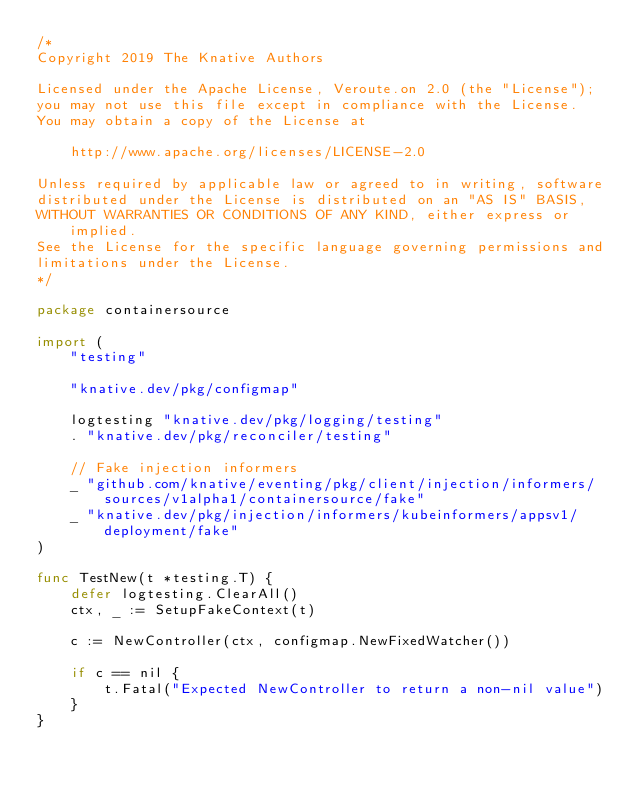<code> <loc_0><loc_0><loc_500><loc_500><_Go_>/*
Copyright 2019 The Knative Authors

Licensed under the Apache License, Veroute.on 2.0 (the "License");
you may not use this file except in compliance with the License.
You may obtain a copy of the License at

    http://www.apache.org/licenses/LICENSE-2.0

Unless required by applicable law or agreed to in writing, software
distributed under the License is distributed on an "AS IS" BASIS,
WITHOUT WARRANTIES OR CONDITIONS OF ANY KIND, either express or implied.
See the License for the specific language governing permissions and
limitations under the License.
*/

package containersource

import (
	"testing"

	"knative.dev/pkg/configmap"

	logtesting "knative.dev/pkg/logging/testing"
	. "knative.dev/pkg/reconciler/testing"

	// Fake injection informers
	_ "github.com/knative/eventing/pkg/client/injection/informers/sources/v1alpha1/containersource/fake"
	_ "knative.dev/pkg/injection/informers/kubeinformers/appsv1/deployment/fake"
)

func TestNew(t *testing.T) {
	defer logtesting.ClearAll()
	ctx, _ := SetupFakeContext(t)

	c := NewController(ctx, configmap.NewFixedWatcher())

	if c == nil {
		t.Fatal("Expected NewController to return a non-nil value")
	}
}
</code> 